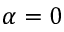Convert formula to latex. <formula><loc_0><loc_0><loc_500><loc_500>\alpha = 0</formula> 